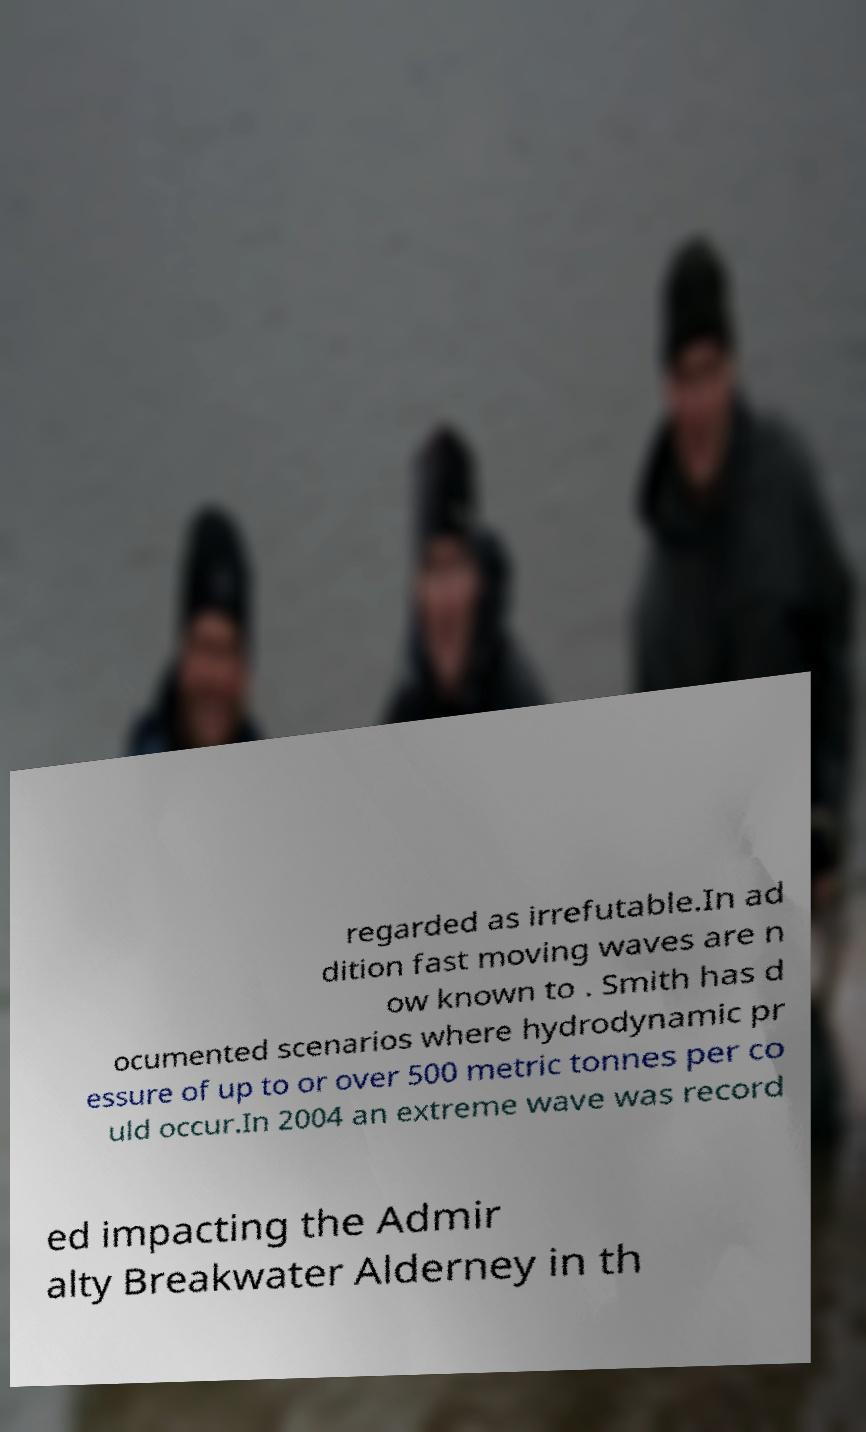Can you read and provide the text displayed in the image?This photo seems to have some interesting text. Can you extract and type it out for me? regarded as irrefutable.In ad dition fast moving waves are n ow known to . Smith has d ocumented scenarios where hydrodynamic pr essure of up to or over 500 metric tonnes per co uld occur.In 2004 an extreme wave was record ed impacting the Admir alty Breakwater Alderney in th 